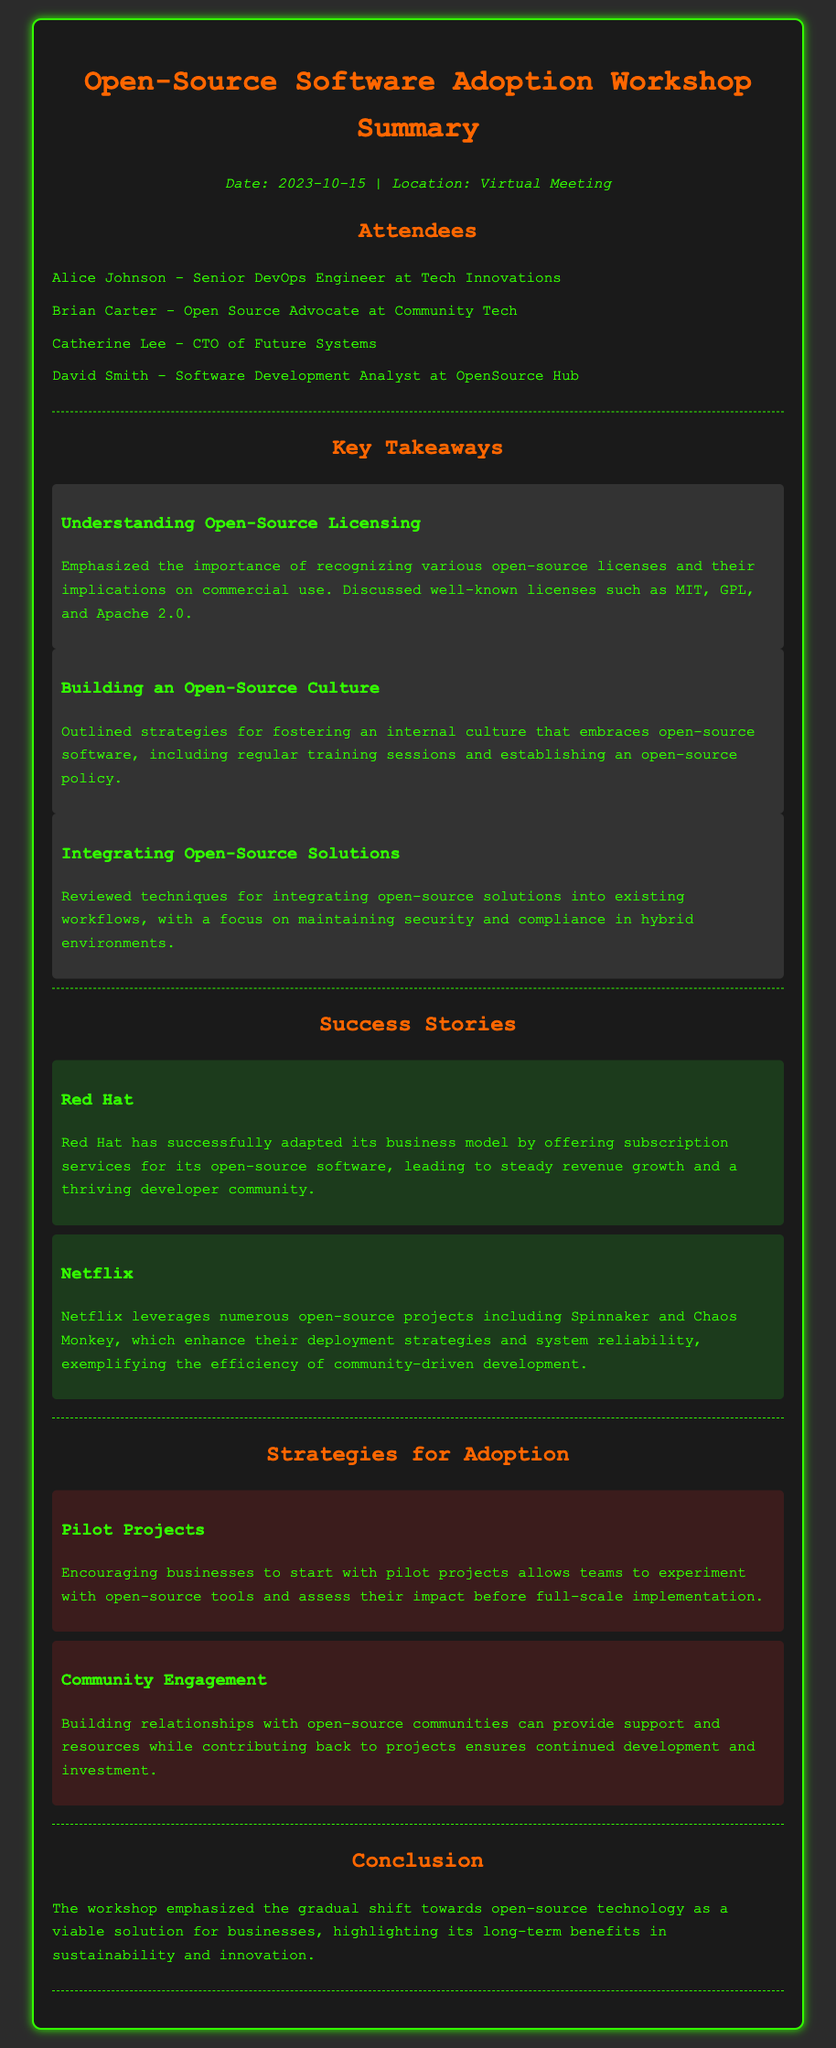What is the date of the workshop? The date of the workshop is explicitly stated in the document.
Answer: 2023-10-15 Who is the CTO of Future Systems? The document lists attendees and their positions, including Catherine Lee as the CTO of Future Systems.
Answer: Catherine Lee What is one of the well-known open-source licenses mentioned? The document outlines open-source licensing, specifically naming some licenses.
Answer: MIT What is a strategy for integrating open-source solutions? The document discusses techniques for integrating open-source solutions and highlights a specific area of focus.
Answer: Maintaining security and compliance What is a success story mentioned in the workshop summary? The summary gives examples of success stories related to open-source software adoption, mentioning specific companies.
Answer: Red Hat What is emphasized as a key aspect of building an open-source culture? A specific approach to fostering a culture of open-source software is discussed, focusing on training.
Answer: Regular training sessions Why should businesses start with pilot projects? The document explains benefits related to pilot projects in the context of experimentation with open-source tools.
Answer: Experiment with tools What did the workshop conclude about open-source technology? The conclusion highlights a broader trend regarding open-source technology and its benefits for businesses.
Answer: Gradual shift toward open-source technology 